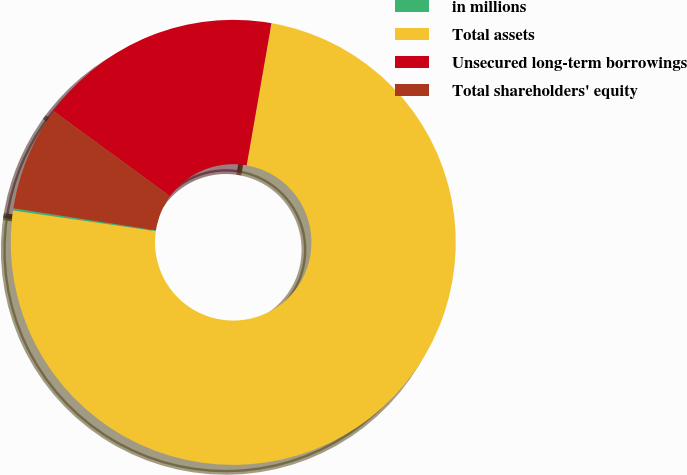Convert chart to OTSL. <chart><loc_0><loc_0><loc_500><loc_500><pie_chart><fcel>in millions<fcel>Total assets<fcel>Unsecured long-term borrowings<fcel>Total shareholders' equity<nl><fcel>0.16%<fcel>74.54%<fcel>17.7%<fcel>7.6%<nl></chart> 